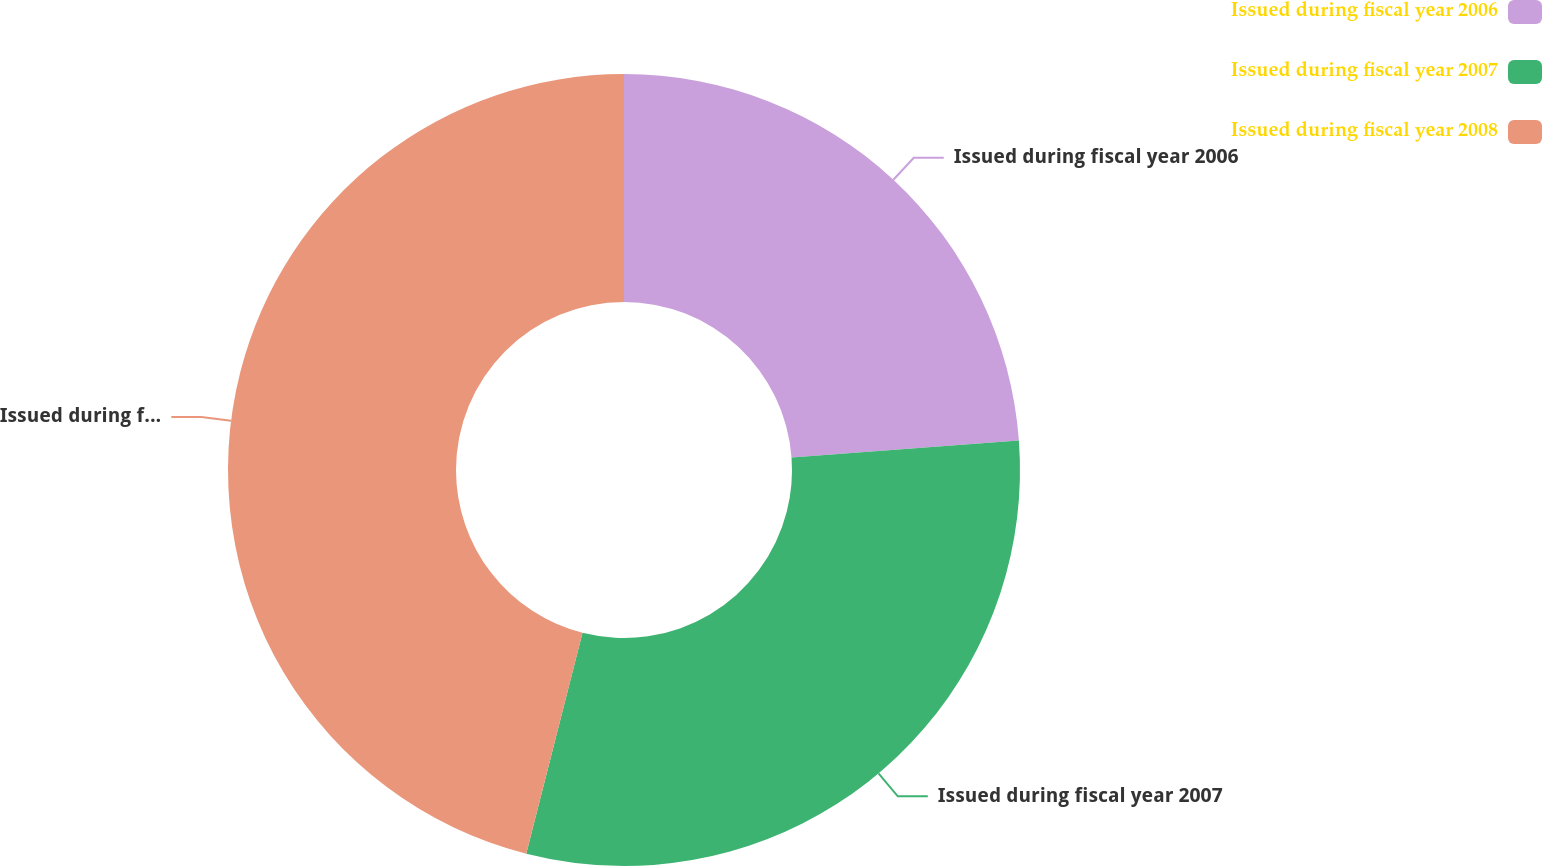Convert chart. <chart><loc_0><loc_0><loc_500><loc_500><pie_chart><fcel>Issued during fiscal year 2006<fcel>Issued during fiscal year 2007<fcel>Issued during fiscal year 2008<nl><fcel>23.81%<fcel>30.16%<fcel>46.03%<nl></chart> 